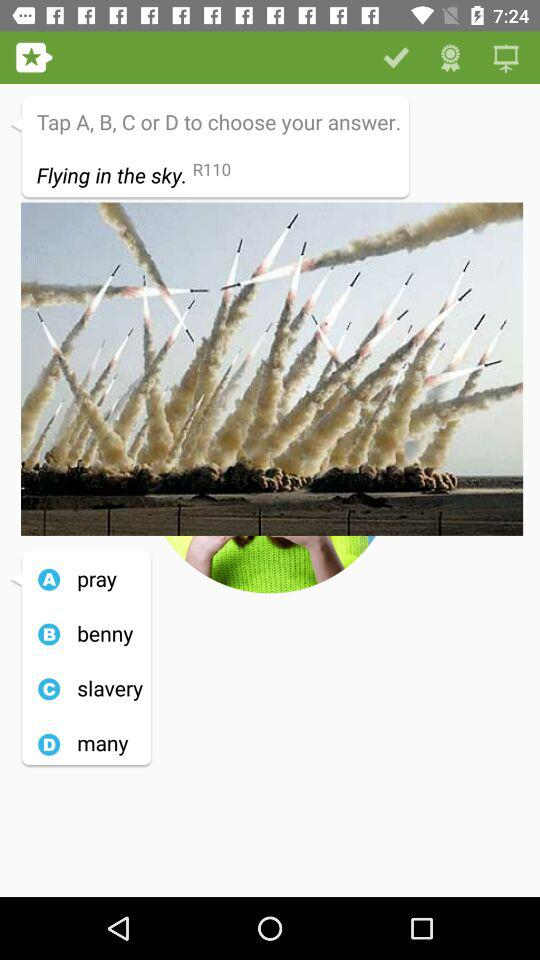What's option "A"? The option "A" is "pray". 